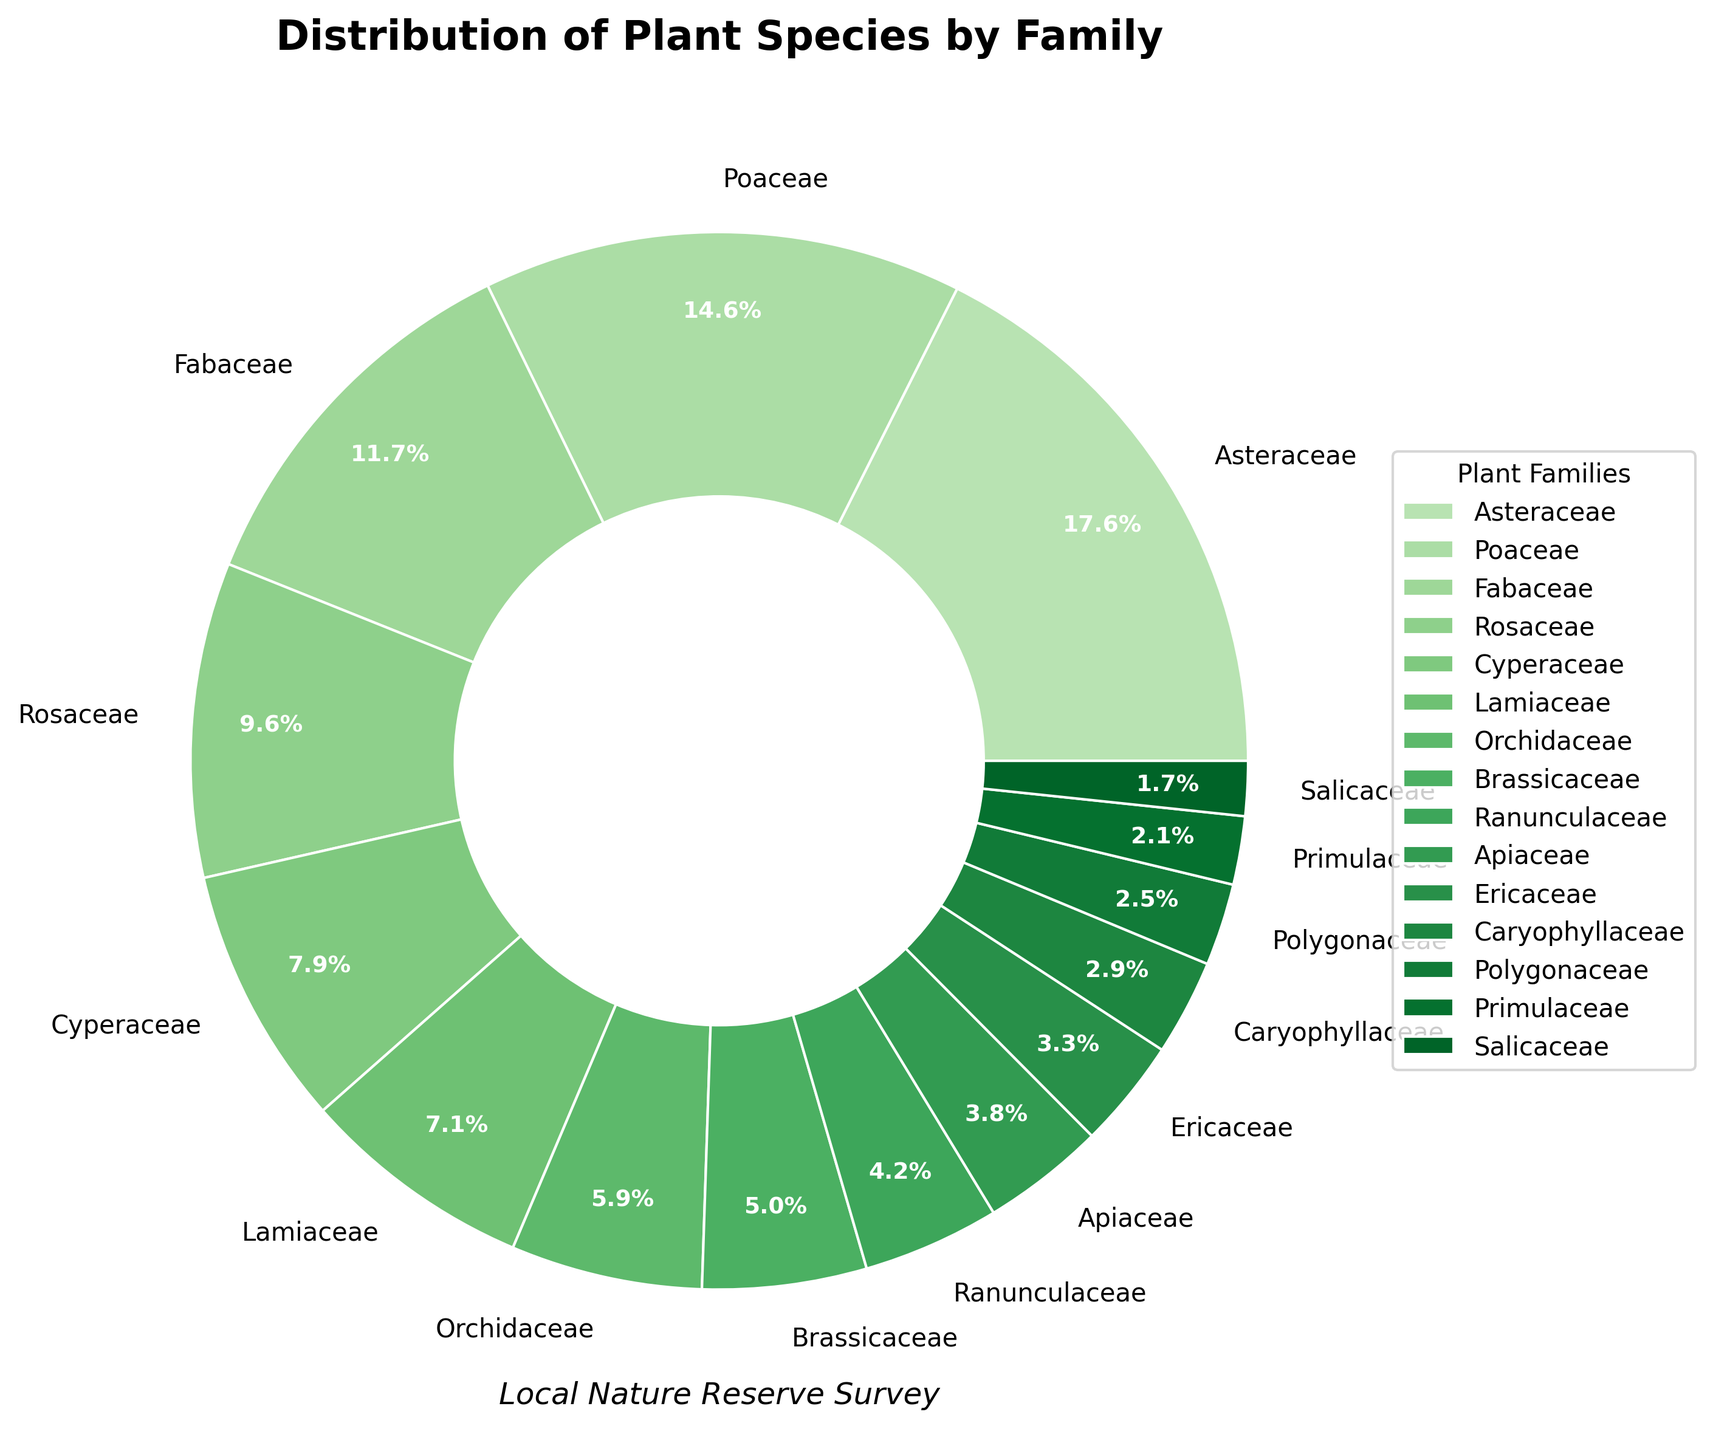Which plant family has the highest percentage of species? The pie chart shows the proportion of each plant family. The wedge with the highest percentage is labeled.
Answer: Asteraceae Which two plant families together make up more than 50% of the species? By examining the chart, the sizes of the wedges indicate the Asteraceae and Poaceae families together. Their percentages are 42 out of 219 and 35 out of 219 respectively. Adding these percentages together gives approximately 35+19=54%.
Answer: Asteraceae and Poaceae How does the percentage of Ranunculaceae compare to that of Caryophyllaceae? Look at the wedges labeled Ranunculaceae and Caryophyllaceae. Ranunculaceae has a larger wedge than Caryophyllaceae. By examining the labels, Ranunculaceae has 10/(total=219) which is more than Caryophyllaceae's 7/(total=219).
Answer: Ranunculaceae is larger than Caryophyllaceae What is the approximate percentage difference between Cyperaceae and Lamiaceae? Identify and compare the wedges for Cyperaceae and Lamiaceae. The chart shows their proportions. Cyperaceae is 19, and Lamiaceae is 17, out of 219. Calculate the percentage for both (19/219)*100, (17/219)*100 and then their difference (approx 8.7 - 7.8).
Answer: Approximately 0.9% What is the combined percentage of Brassicaceae and Orchidaceae? The pie chart indicates the percentages. Summing up Brassicaceae(12) and Orchidaceae(14 percentages as fraction of total species, approximately (12+14)/219 = (total 26/219) *100. Calculate total to get percentage.
Answer: 11.9% How many more species are there in the Fabaceae family compared to the Apiaceae family? By referencing the pie chart, locate the Fabaceae and Apiaceae wedges, and compare the labeled species counts. Subtract Apiaceae's 9 from Fabaceae's 28.
Answer: 19 more species Which family has more species: Rosaceae or Ericaceae? The chart labels indicate the species counts for each family. Rosaceae has 23 species, whereas Ericaceae has 8. Comparing these counts shows that Rosaceae has more.
Answer: Rosaceae If the Rosaceae and Salicaceae families combined, would they have more species than the Poaceae family? By referencing the labeled species counts, sum Rosaceae (23) and Salicaceae (4) and compare to Poaceae (35). The sum is 27, which is less than 35.
Answer: No What is the average number of species per family? From the pie chart, sum all species across families (total 219), then divide by the number of families (15). 219/15 = 14.6 species per family.
Answer: 14.6 If you group families with less than 10 species, how many families fall into this category? The chart labels the families by species count. Count the number of wedges representing families with fewer than 10 species (Apiaceae, Ericaceae, Caryophyllaceae, Polygonaceae, Primulaceae, Salicaceae). There are six families.
Answer: 6 